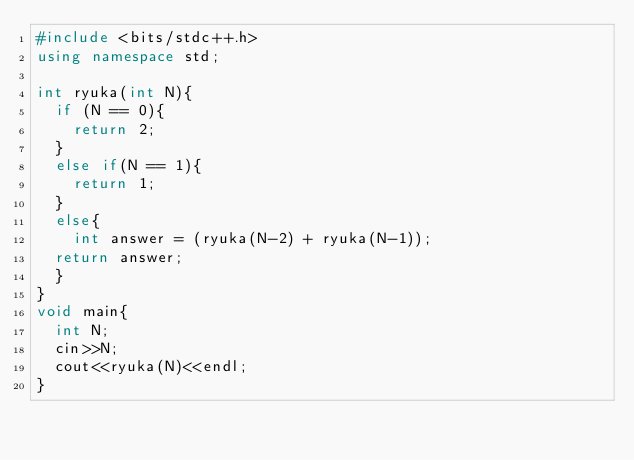<code> <loc_0><loc_0><loc_500><loc_500><_C++_>#include <bits/stdc++.h>
using namespace std;

int ryuka(int N){
  if (N == 0){
    return 2;
  }
  else if(N == 1){
    return 1;
  }
  else{
    int answer = (ryuka(N-2) + ryuka(N-1));
  return answer;
  }
}
void main{
  int N;
  cin>>N;
  cout<<ryuka(N)<<endl;
}  </code> 